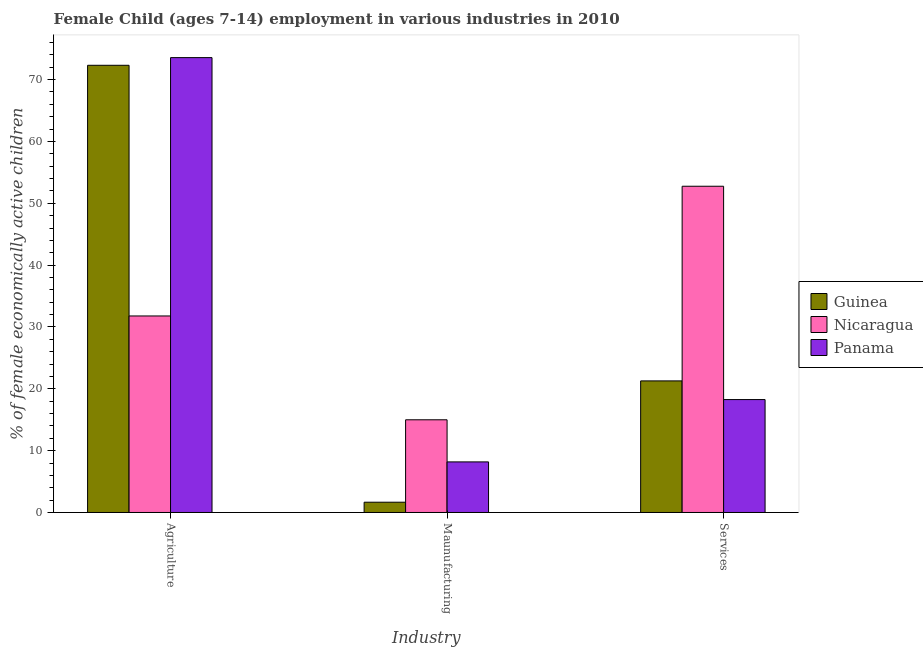How many groups of bars are there?
Offer a terse response. 3. How many bars are there on the 1st tick from the right?
Your response must be concise. 3. What is the label of the 2nd group of bars from the left?
Your answer should be very brief. Maunufacturing. What is the percentage of economically active children in services in Guinea?
Give a very brief answer. 21.28. Across all countries, what is the maximum percentage of economically active children in manufacturing?
Ensure brevity in your answer.  14.99. Across all countries, what is the minimum percentage of economically active children in agriculture?
Your answer should be very brief. 31.78. In which country was the percentage of economically active children in manufacturing maximum?
Give a very brief answer. Nicaragua. In which country was the percentage of economically active children in agriculture minimum?
Keep it short and to the point. Nicaragua. What is the total percentage of economically active children in services in the graph?
Give a very brief answer. 92.3. What is the difference between the percentage of economically active children in agriculture in Guinea and that in Nicaragua?
Ensure brevity in your answer.  40.54. What is the difference between the percentage of economically active children in manufacturing in Nicaragua and the percentage of economically active children in agriculture in Panama?
Offer a very short reply. -58.57. What is the average percentage of economically active children in services per country?
Keep it short and to the point. 30.77. What is the difference between the percentage of economically active children in agriculture and percentage of economically active children in services in Nicaragua?
Provide a succinct answer. -20.98. In how many countries, is the percentage of economically active children in services greater than 28 %?
Offer a very short reply. 1. What is the ratio of the percentage of economically active children in services in Guinea to that in Nicaragua?
Your answer should be compact. 0.4. Is the percentage of economically active children in manufacturing in Panama less than that in Guinea?
Offer a very short reply. No. What is the difference between the highest and the second highest percentage of economically active children in manufacturing?
Provide a succinct answer. 6.81. What is the difference between the highest and the lowest percentage of economically active children in manufacturing?
Keep it short and to the point. 13.33. Is the sum of the percentage of economically active children in manufacturing in Panama and Nicaragua greater than the maximum percentage of economically active children in agriculture across all countries?
Give a very brief answer. No. What does the 2nd bar from the left in Agriculture represents?
Keep it short and to the point. Nicaragua. What does the 1st bar from the right in Services represents?
Provide a short and direct response. Panama. Is it the case that in every country, the sum of the percentage of economically active children in agriculture and percentage of economically active children in manufacturing is greater than the percentage of economically active children in services?
Your answer should be compact. No. How many bars are there?
Provide a short and direct response. 9. What is the difference between two consecutive major ticks on the Y-axis?
Provide a short and direct response. 10. Where does the legend appear in the graph?
Offer a terse response. Center right. How many legend labels are there?
Ensure brevity in your answer.  3. What is the title of the graph?
Your answer should be compact. Female Child (ages 7-14) employment in various industries in 2010. Does "Mongolia" appear as one of the legend labels in the graph?
Offer a terse response. No. What is the label or title of the X-axis?
Ensure brevity in your answer.  Industry. What is the label or title of the Y-axis?
Offer a terse response. % of female economically active children. What is the % of female economically active children in Guinea in Agriculture?
Make the answer very short. 72.32. What is the % of female economically active children in Nicaragua in Agriculture?
Provide a short and direct response. 31.78. What is the % of female economically active children in Panama in Agriculture?
Provide a short and direct response. 73.56. What is the % of female economically active children in Guinea in Maunufacturing?
Make the answer very short. 1.66. What is the % of female economically active children of Nicaragua in Maunufacturing?
Give a very brief answer. 14.99. What is the % of female economically active children of Panama in Maunufacturing?
Provide a succinct answer. 8.18. What is the % of female economically active children of Guinea in Services?
Make the answer very short. 21.28. What is the % of female economically active children of Nicaragua in Services?
Ensure brevity in your answer.  52.76. What is the % of female economically active children of Panama in Services?
Ensure brevity in your answer.  18.26. Across all Industry, what is the maximum % of female economically active children of Guinea?
Provide a short and direct response. 72.32. Across all Industry, what is the maximum % of female economically active children in Nicaragua?
Give a very brief answer. 52.76. Across all Industry, what is the maximum % of female economically active children in Panama?
Give a very brief answer. 73.56. Across all Industry, what is the minimum % of female economically active children of Guinea?
Your answer should be very brief. 1.66. Across all Industry, what is the minimum % of female economically active children of Nicaragua?
Offer a terse response. 14.99. Across all Industry, what is the minimum % of female economically active children in Panama?
Provide a short and direct response. 8.18. What is the total % of female economically active children of Guinea in the graph?
Offer a very short reply. 95.26. What is the total % of female economically active children in Nicaragua in the graph?
Offer a terse response. 99.53. What is the total % of female economically active children in Panama in the graph?
Make the answer very short. 100. What is the difference between the % of female economically active children of Guinea in Agriculture and that in Maunufacturing?
Offer a very short reply. 70.66. What is the difference between the % of female economically active children in Nicaragua in Agriculture and that in Maunufacturing?
Provide a short and direct response. 16.79. What is the difference between the % of female economically active children of Panama in Agriculture and that in Maunufacturing?
Your answer should be very brief. 65.38. What is the difference between the % of female economically active children of Guinea in Agriculture and that in Services?
Keep it short and to the point. 51.04. What is the difference between the % of female economically active children in Nicaragua in Agriculture and that in Services?
Offer a terse response. -20.98. What is the difference between the % of female economically active children of Panama in Agriculture and that in Services?
Your answer should be compact. 55.3. What is the difference between the % of female economically active children of Guinea in Maunufacturing and that in Services?
Your answer should be very brief. -19.62. What is the difference between the % of female economically active children in Nicaragua in Maunufacturing and that in Services?
Give a very brief answer. -37.77. What is the difference between the % of female economically active children in Panama in Maunufacturing and that in Services?
Provide a succinct answer. -10.08. What is the difference between the % of female economically active children in Guinea in Agriculture and the % of female economically active children in Nicaragua in Maunufacturing?
Offer a terse response. 57.33. What is the difference between the % of female economically active children in Guinea in Agriculture and the % of female economically active children in Panama in Maunufacturing?
Keep it short and to the point. 64.14. What is the difference between the % of female economically active children in Nicaragua in Agriculture and the % of female economically active children in Panama in Maunufacturing?
Provide a succinct answer. 23.6. What is the difference between the % of female economically active children in Guinea in Agriculture and the % of female economically active children in Nicaragua in Services?
Provide a short and direct response. 19.56. What is the difference between the % of female economically active children of Guinea in Agriculture and the % of female economically active children of Panama in Services?
Provide a short and direct response. 54.06. What is the difference between the % of female economically active children of Nicaragua in Agriculture and the % of female economically active children of Panama in Services?
Your response must be concise. 13.52. What is the difference between the % of female economically active children of Guinea in Maunufacturing and the % of female economically active children of Nicaragua in Services?
Make the answer very short. -51.1. What is the difference between the % of female economically active children in Guinea in Maunufacturing and the % of female economically active children in Panama in Services?
Your response must be concise. -16.6. What is the difference between the % of female economically active children in Nicaragua in Maunufacturing and the % of female economically active children in Panama in Services?
Your response must be concise. -3.27. What is the average % of female economically active children in Guinea per Industry?
Ensure brevity in your answer.  31.75. What is the average % of female economically active children in Nicaragua per Industry?
Keep it short and to the point. 33.18. What is the average % of female economically active children of Panama per Industry?
Provide a succinct answer. 33.33. What is the difference between the % of female economically active children in Guinea and % of female economically active children in Nicaragua in Agriculture?
Provide a short and direct response. 40.54. What is the difference between the % of female economically active children in Guinea and % of female economically active children in Panama in Agriculture?
Ensure brevity in your answer.  -1.24. What is the difference between the % of female economically active children of Nicaragua and % of female economically active children of Panama in Agriculture?
Keep it short and to the point. -41.78. What is the difference between the % of female economically active children in Guinea and % of female economically active children in Nicaragua in Maunufacturing?
Ensure brevity in your answer.  -13.33. What is the difference between the % of female economically active children in Guinea and % of female economically active children in Panama in Maunufacturing?
Provide a short and direct response. -6.52. What is the difference between the % of female economically active children in Nicaragua and % of female economically active children in Panama in Maunufacturing?
Provide a succinct answer. 6.81. What is the difference between the % of female economically active children of Guinea and % of female economically active children of Nicaragua in Services?
Your response must be concise. -31.48. What is the difference between the % of female economically active children in Guinea and % of female economically active children in Panama in Services?
Ensure brevity in your answer.  3.02. What is the difference between the % of female economically active children in Nicaragua and % of female economically active children in Panama in Services?
Make the answer very short. 34.5. What is the ratio of the % of female economically active children of Guinea in Agriculture to that in Maunufacturing?
Your answer should be very brief. 43.57. What is the ratio of the % of female economically active children of Nicaragua in Agriculture to that in Maunufacturing?
Your answer should be compact. 2.12. What is the ratio of the % of female economically active children of Panama in Agriculture to that in Maunufacturing?
Keep it short and to the point. 8.99. What is the ratio of the % of female economically active children in Guinea in Agriculture to that in Services?
Offer a terse response. 3.4. What is the ratio of the % of female economically active children of Nicaragua in Agriculture to that in Services?
Offer a terse response. 0.6. What is the ratio of the % of female economically active children in Panama in Agriculture to that in Services?
Offer a terse response. 4.03. What is the ratio of the % of female economically active children of Guinea in Maunufacturing to that in Services?
Your answer should be compact. 0.08. What is the ratio of the % of female economically active children in Nicaragua in Maunufacturing to that in Services?
Your answer should be compact. 0.28. What is the ratio of the % of female economically active children of Panama in Maunufacturing to that in Services?
Provide a succinct answer. 0.45. What is the difference between the highest and the second highest % of female economically active children in Guinea?
Your answer should be compact. 51.04. What is the difference between the highest and the second highest % of female economically active children of Nicaragua?
Keep it short and to the point. 20.98. What is the difference between the highest and the second highest % of female economically active children of Panama?
Your answer should be compact. 55.3. What is the difference between the highest and the lowest % of female economically active children in Guinea?
Give a very brief answer. 70.66. What is the difference between the highest and the lowest % of female economically active children of Nicaragua?
Your answer should be very brief. 37.77. What is the difference between the highest and the lowest % of female economically active children in Panama?
Your answer should be very brief. 65.38. 